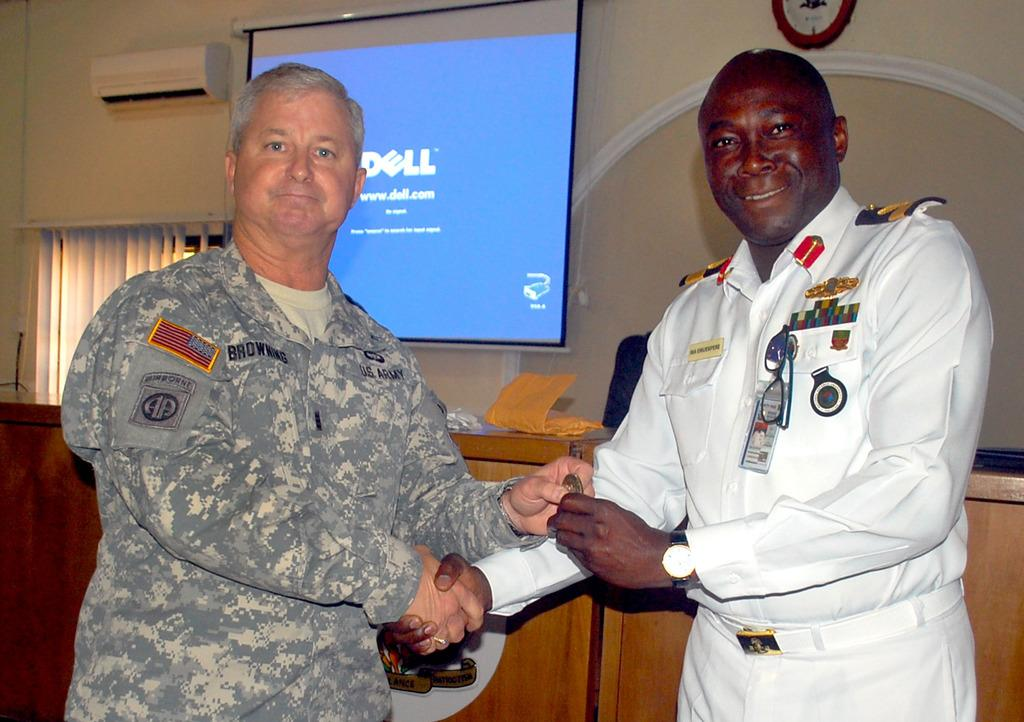<image>
Offer a succinct explanation of the picture presented. a screen that has the word Dell on it 